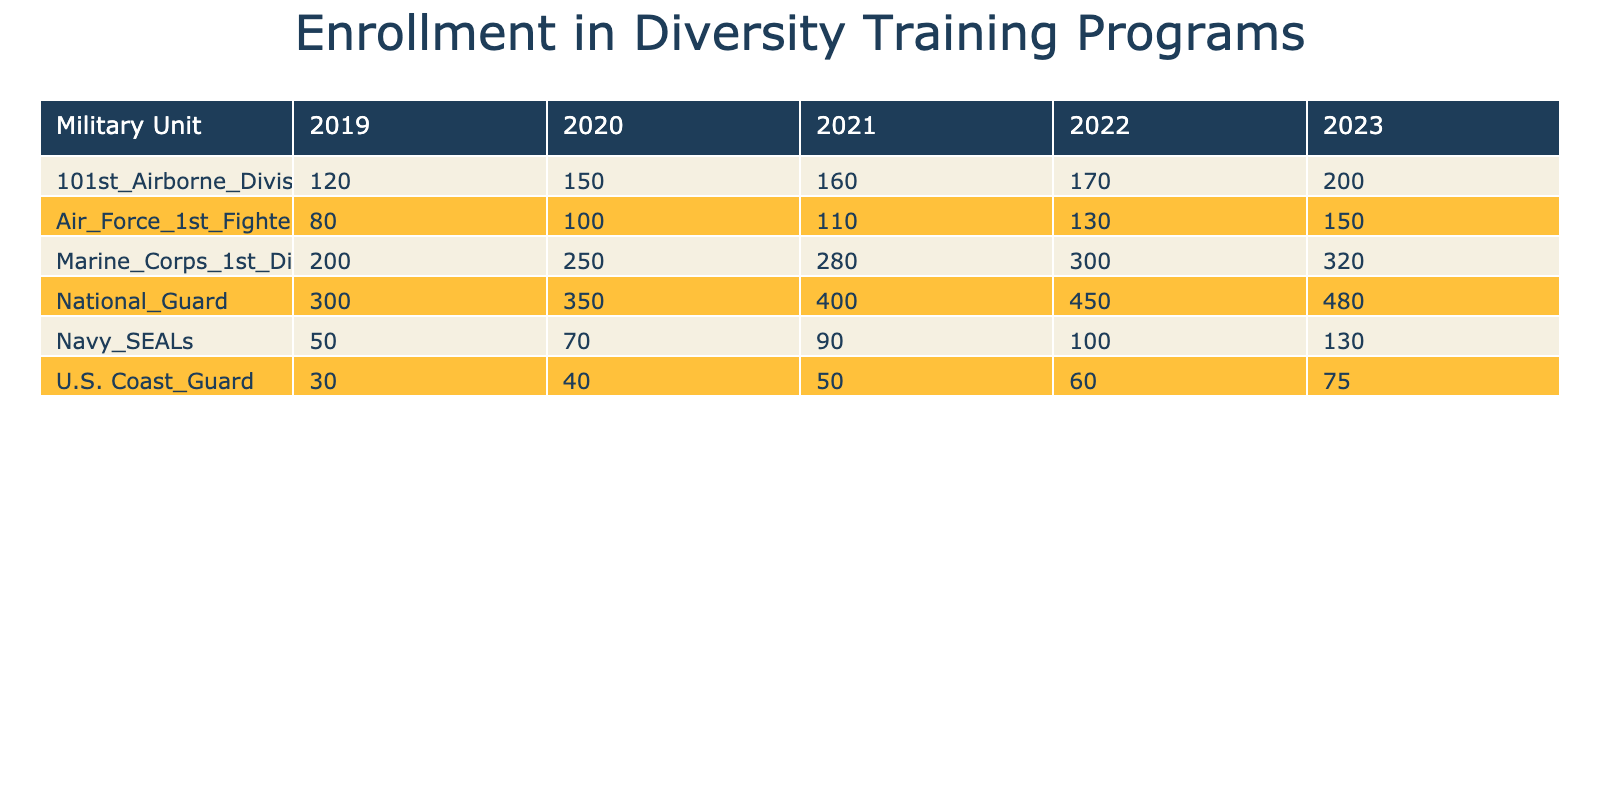What was the enrollment number in the National Guard in 2021? The table shows that the enrollment number for the National Guard in 2021 is listed directly. By checking that row for the National Guard and the year 2021, we find the number.
Answer: 400 Which military unit had the highest enrollment in 2023? Examining the last column of the table for the year 2023, we find the highest number listed for the Marine Corps 1st Division with 320 enrollments.
Answer: Marine Corps 1st Division What was the total enrollment number for the 101st Airborne Division over the five years? To find the total, sum the enrollment numbers from 2019 to 2023: 120 + 150 + 160 + 170 + 200 = 900.
Answer: 900 Did the Navy SEALs have a decline in enrollment from 2022 to 2023? Comparing the values for the Navy SEALs in 2022 (100) and 2023 (130), we find there was an increase, indicating no decline occurred.
Answer: No What is the average enrollment number for the U.S. Coast Guard over the five years? The enrollment numbers for the U.S. Coast Guard are 30, 40, 50, 60, and 75. Summing these gives 255. To find the average, divide by the number of years, which is 5: 255 / 5 = 51.
Answer: 51 Which military unit had the least enrollment in 2019, and how many were enrolled? By looking at the first year's enrollment numbers, the U.S. Coast Guard had the least enrollment at 30, compared to other units.
Answer: U.S. Coast Guard, 30 How much did enrollment in the National Guard increase from 2019 to 2023? The enrollment numbers for the National Guard in 2019 is 300 and in 2023 is 480. To calculate the increase, subtract: 480 - 300 = 180.
Answer: 180 Did the enrollment numbers for the Marine Corps 1st Division increase each year? By examining the enrollment numbers year by year for the Marine Corps 1st Division, we find they rose from 200 in 2019 to 320 in 2023, confirming an increase every year.
Answer: Yes 